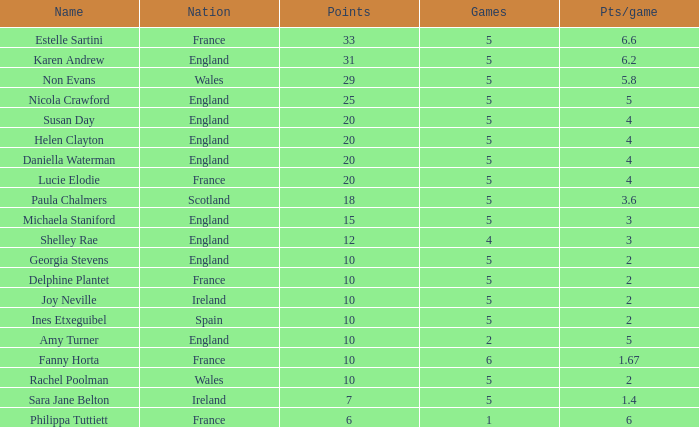Can you tell me the lowest Games that has the Pts/game larger than 1.4 and the Points of 20, and the Name of susan day? 5.0. 